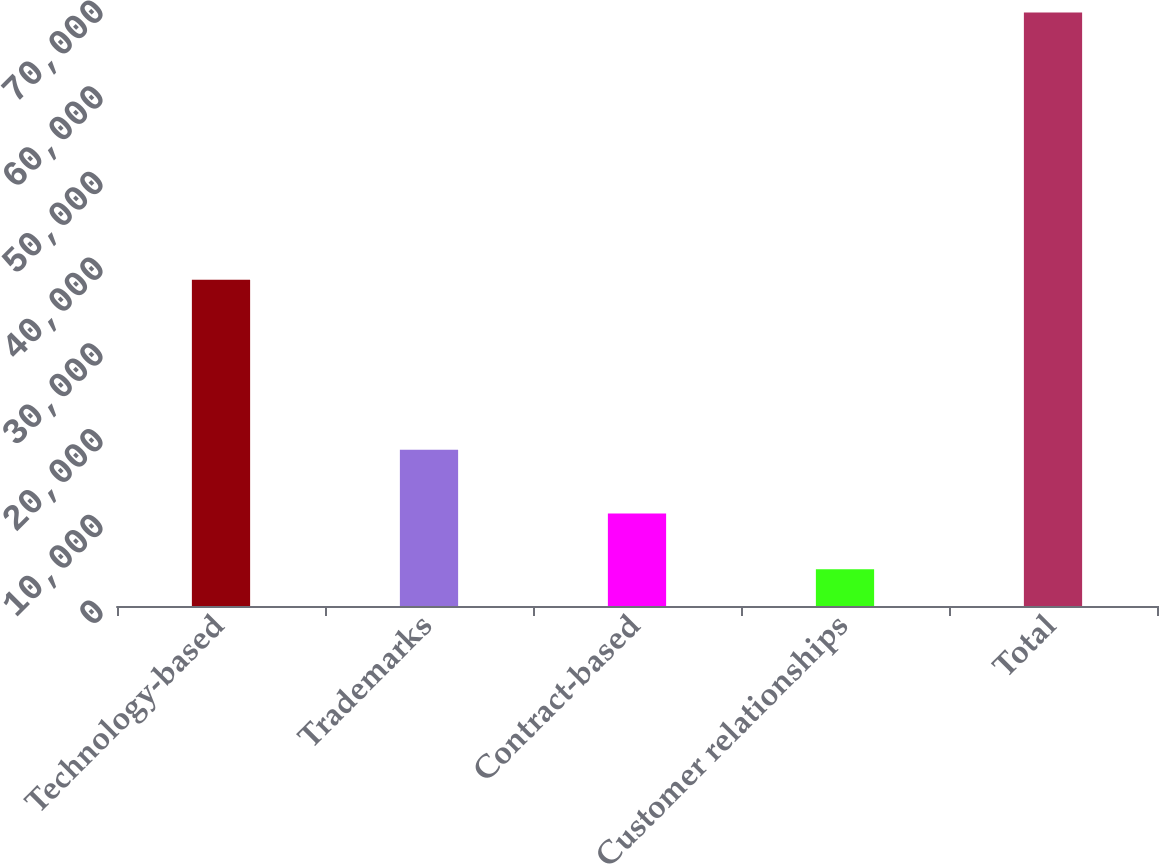Convert chart. <chart><loc_0><loc_0><loc_500><loc_500><bar_chart><fcel>Technology-based<fcel>Trademarks<fcel>Contract-based<fcel>Customer relationships<fcel>Total<nl><fcel>38066<fcel>18236<fcel>10789.2<fcel>4294<fcel>69246<nl></chart> 